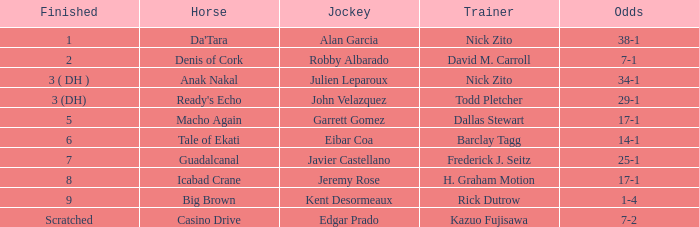Who is the Jockey for guadalcanal? Javier Castellano. 